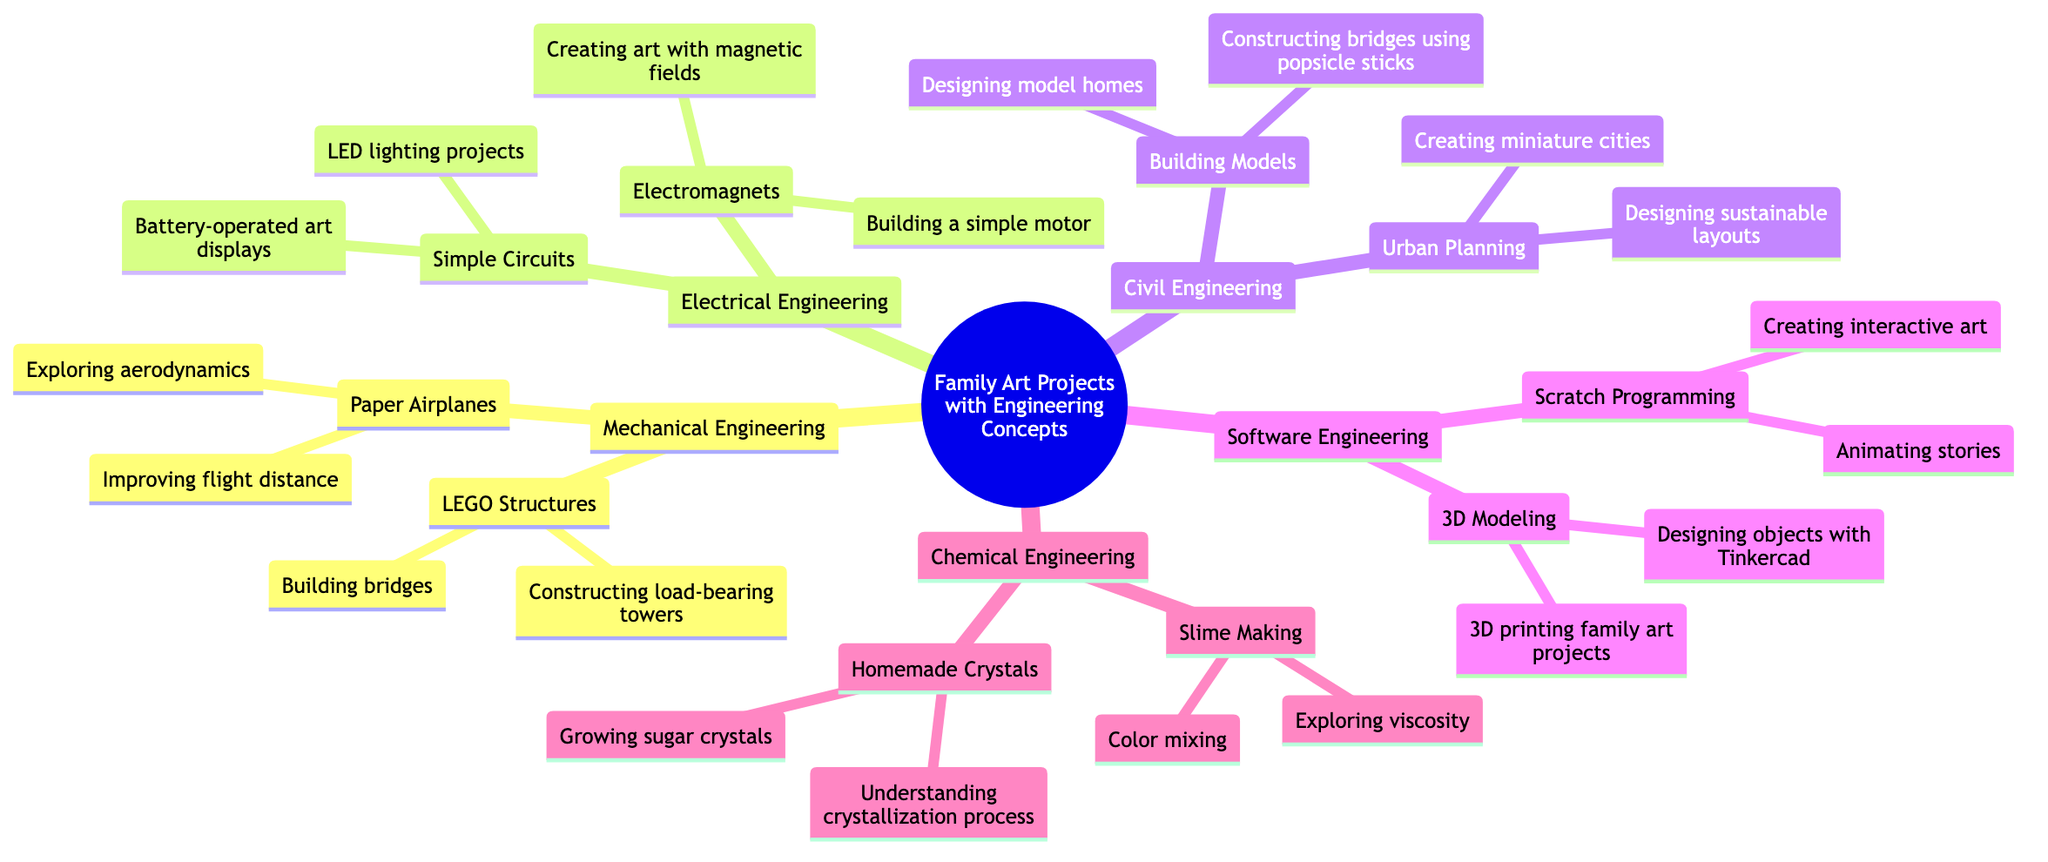What is the central idea of the mind map? The central idea is explicitly labeled at the root of the diagram as "Family Art Projects with Engineering Concepts."
Answer: Family Art Projects with Engineering Concepts How many main branches are there in the diagram? Counting the main categories representing branches from the central idea, there are a total of five: Mechanical Engineering, Electrical Engineering, Civil Engineering, Software Engineering, and Chemical Engineering.
Answer: 5 What activity is associated with "Building bridges"? This activity falls under the sub-branch "LEGO Structures" in the "Mechanical Engineering" branch of the mind map.
Answer: Building bridges Which sub-branch has an activity focused on "Designing sustainable layouts"? This activity is part of the "Urban Planning" sub-branch, which is under the "Civil Engineering" main branch.
Answer: Urban Planning What type of engineering concepts are explored in "Simple Circuits"? The "Simple Circuits" sub-branch is categorized under Electrical Engineering, which deals with electrical systems and components.
Answer: Electrical Engineering What are the two main activities listed under "3D Modeling"? The activities are "Designing objects with Tinkercad" and "3D printing family art projects," both relevant to creating three-dimensional designs and producing them physically.
Answer: Designing objects with Tinkercad, 3D printing family art projects Which main branch explores "Exploring viscosity"? "Exploring viscosity" is an activity found under the "Slime Making" sub-branch, which is part of the "Chemical Engineering" branch.
Answer: Chemical Engineering What is the relationship between "Scratch Programming" and "Animating stories"? "Animating stories" is an activity that is categorized as a part of the "Scratch Programming" sub-branch under the "Software Engineering" main branch, showing that Scratch Programming includes this activity.
Answer: Scratch Programming How many activities are listed under "Electromagnets"? The "Electromagnets" sub-branch lists two activities: "Creating art with magnetic fields" and "Building a simple motor." Thus, there are two activities in total.
Answer: 2 